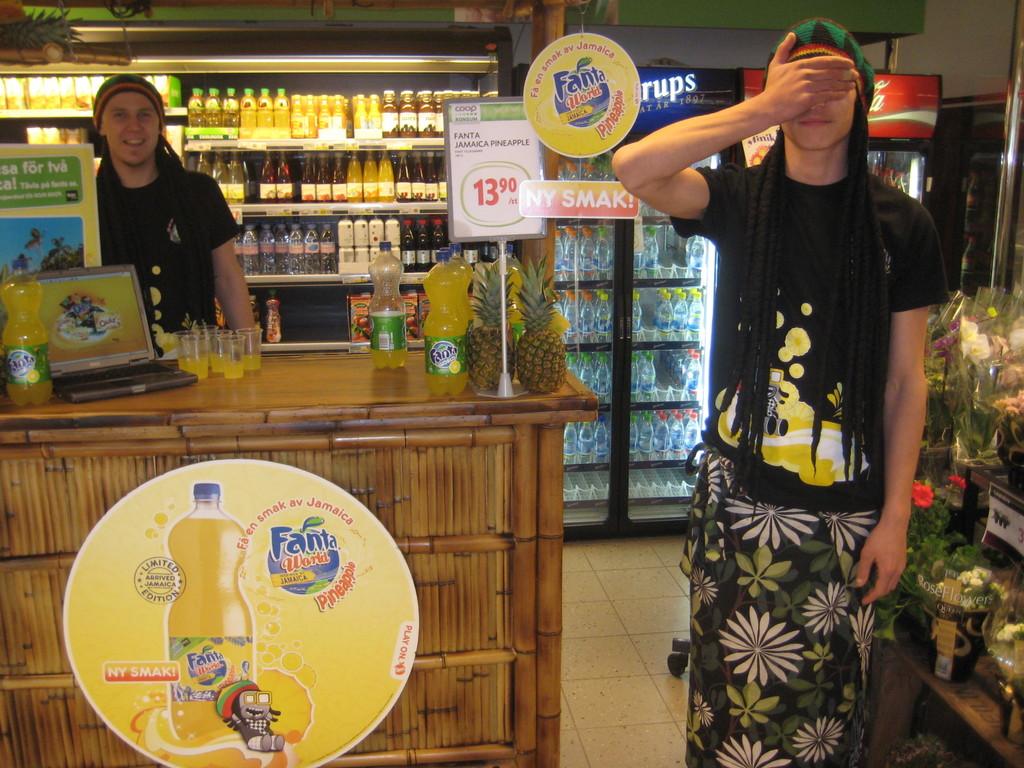How much is fanta pineapple?
Make the answer very short. 13.90. What kind of drink is on the sign?
Keep it short and to the point. Fanta. 